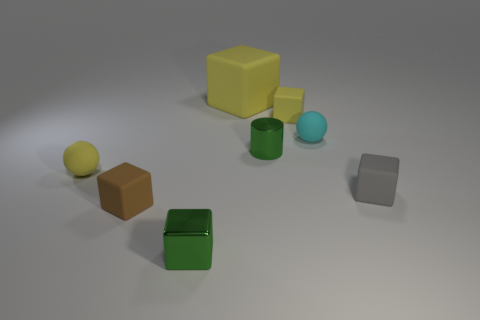Subtract 1 blocks. How many blocks are left? 4 Subtract all green cubes. How many cubes are left? 4 Subtract all small green shiny cubes. How many cubes are left? 4 Subtract all brown blocks. Subtract all blue cylinders. How many blocks are left? 4 Add 1 brown matte things. How many objects exist? 9 Subtract all spheres. How many objects are left? 6 Add 2 tiny matte blocks. How many tiny matte blocks are left? 5 Add 1 cyan rubber things. How many cyan rubber things exist? 2 Subtract 1 yellow cubes. How many objects are left? 7 Subtract all tiny green objects. Subtract all tiny green metallic blocks. How many objects are left? 5 